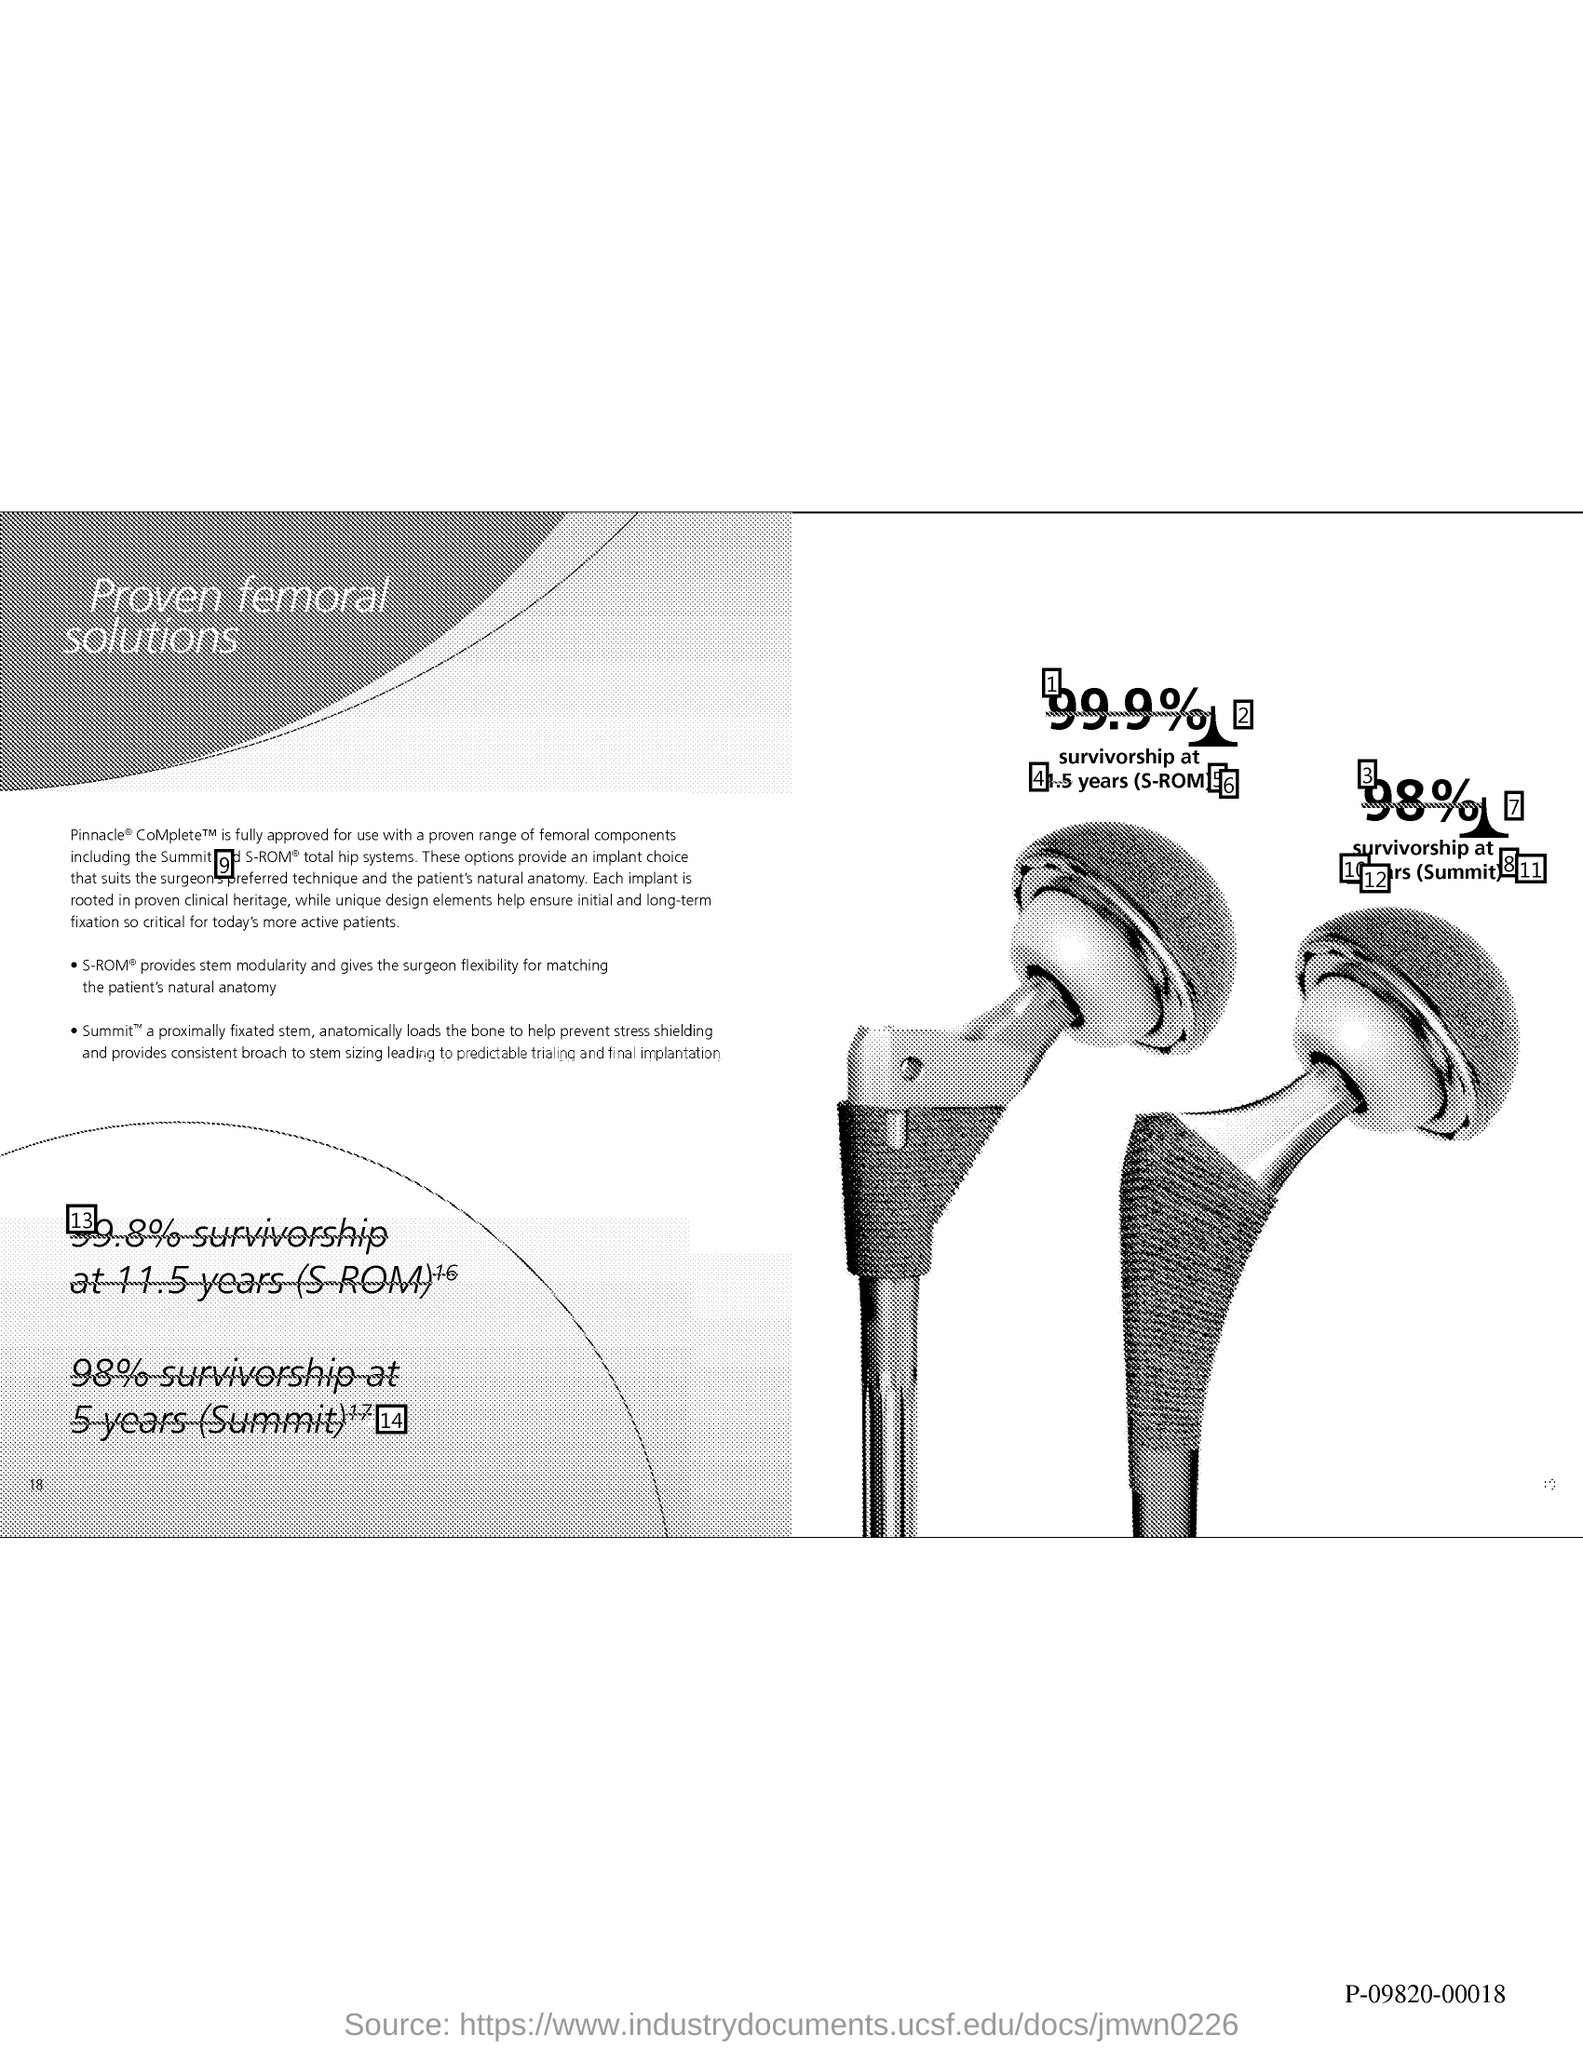Identify some key points in this picture. The title of the document is 'Proven femoral solutions'. 